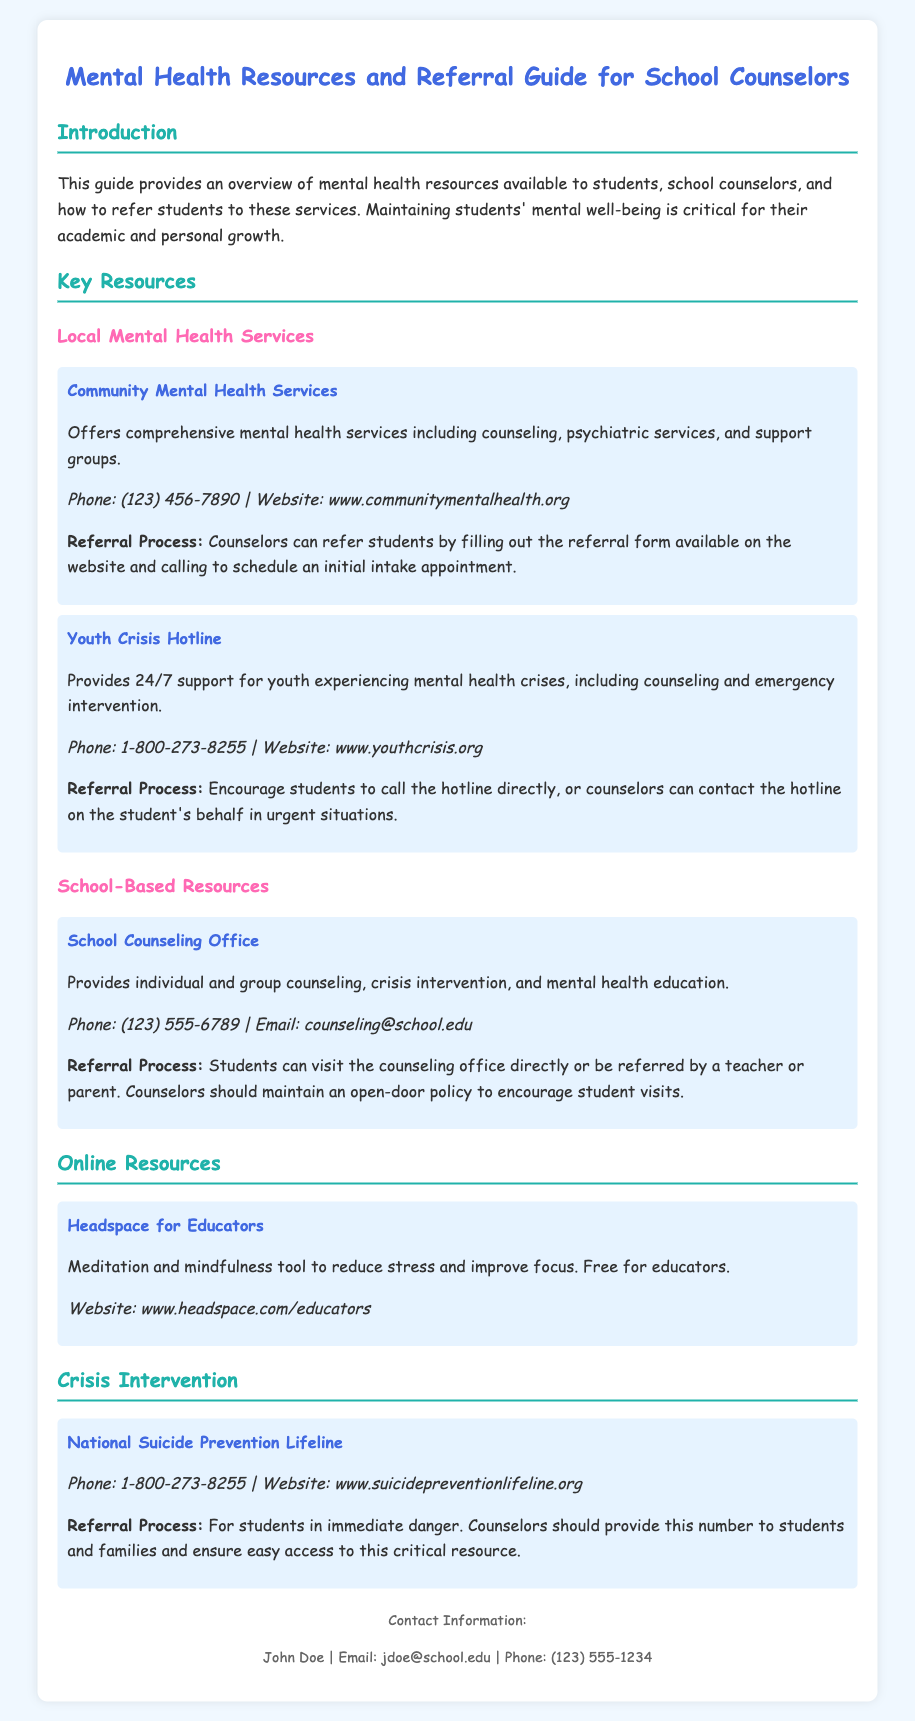What is the main purpose of this guide? The guide provides an overview of mental health resources available to students, school counselors, and referral processes.
Answer: Overview of mental health resources What is the phone number for Community Mental Health Services? The document lists the contact information for Community Mental Health Services, which includes a phone number.
Answer: (123) 456-7890 What service does the Youth Crisis Hotline provide? The document states that the Youth Crisis Hotline provides support for youth experiencing mental health crises.
Answer: 24/7 support How can students refer themselves to the School Counseling Office? The document explains the referral process for the School Counseling Office, focusing on how students can access the service.
Answer: Visit the counseling office directly What is the website for Headspace for Educators? The document specifies the web resource available for educators and includes its URL.
Answer: www.headspace.com/educators What type of resource is the National Suicide Prevention Lifeline categorized as? The document classifies various types of resources, including crisis intervention resources, for mental health support.
Answer: Crisis intervention How can counselors refer students to Community Mental Health Services? The document describes the referral process for Community Mental Health Services, specifically how counselors should proceed.
Answer: Fill out the referral form What is the contact email for the School Counseling Office? The document provides the contact information for the School Counseling Office, including an email address.
Answer: counseling@school.edu 